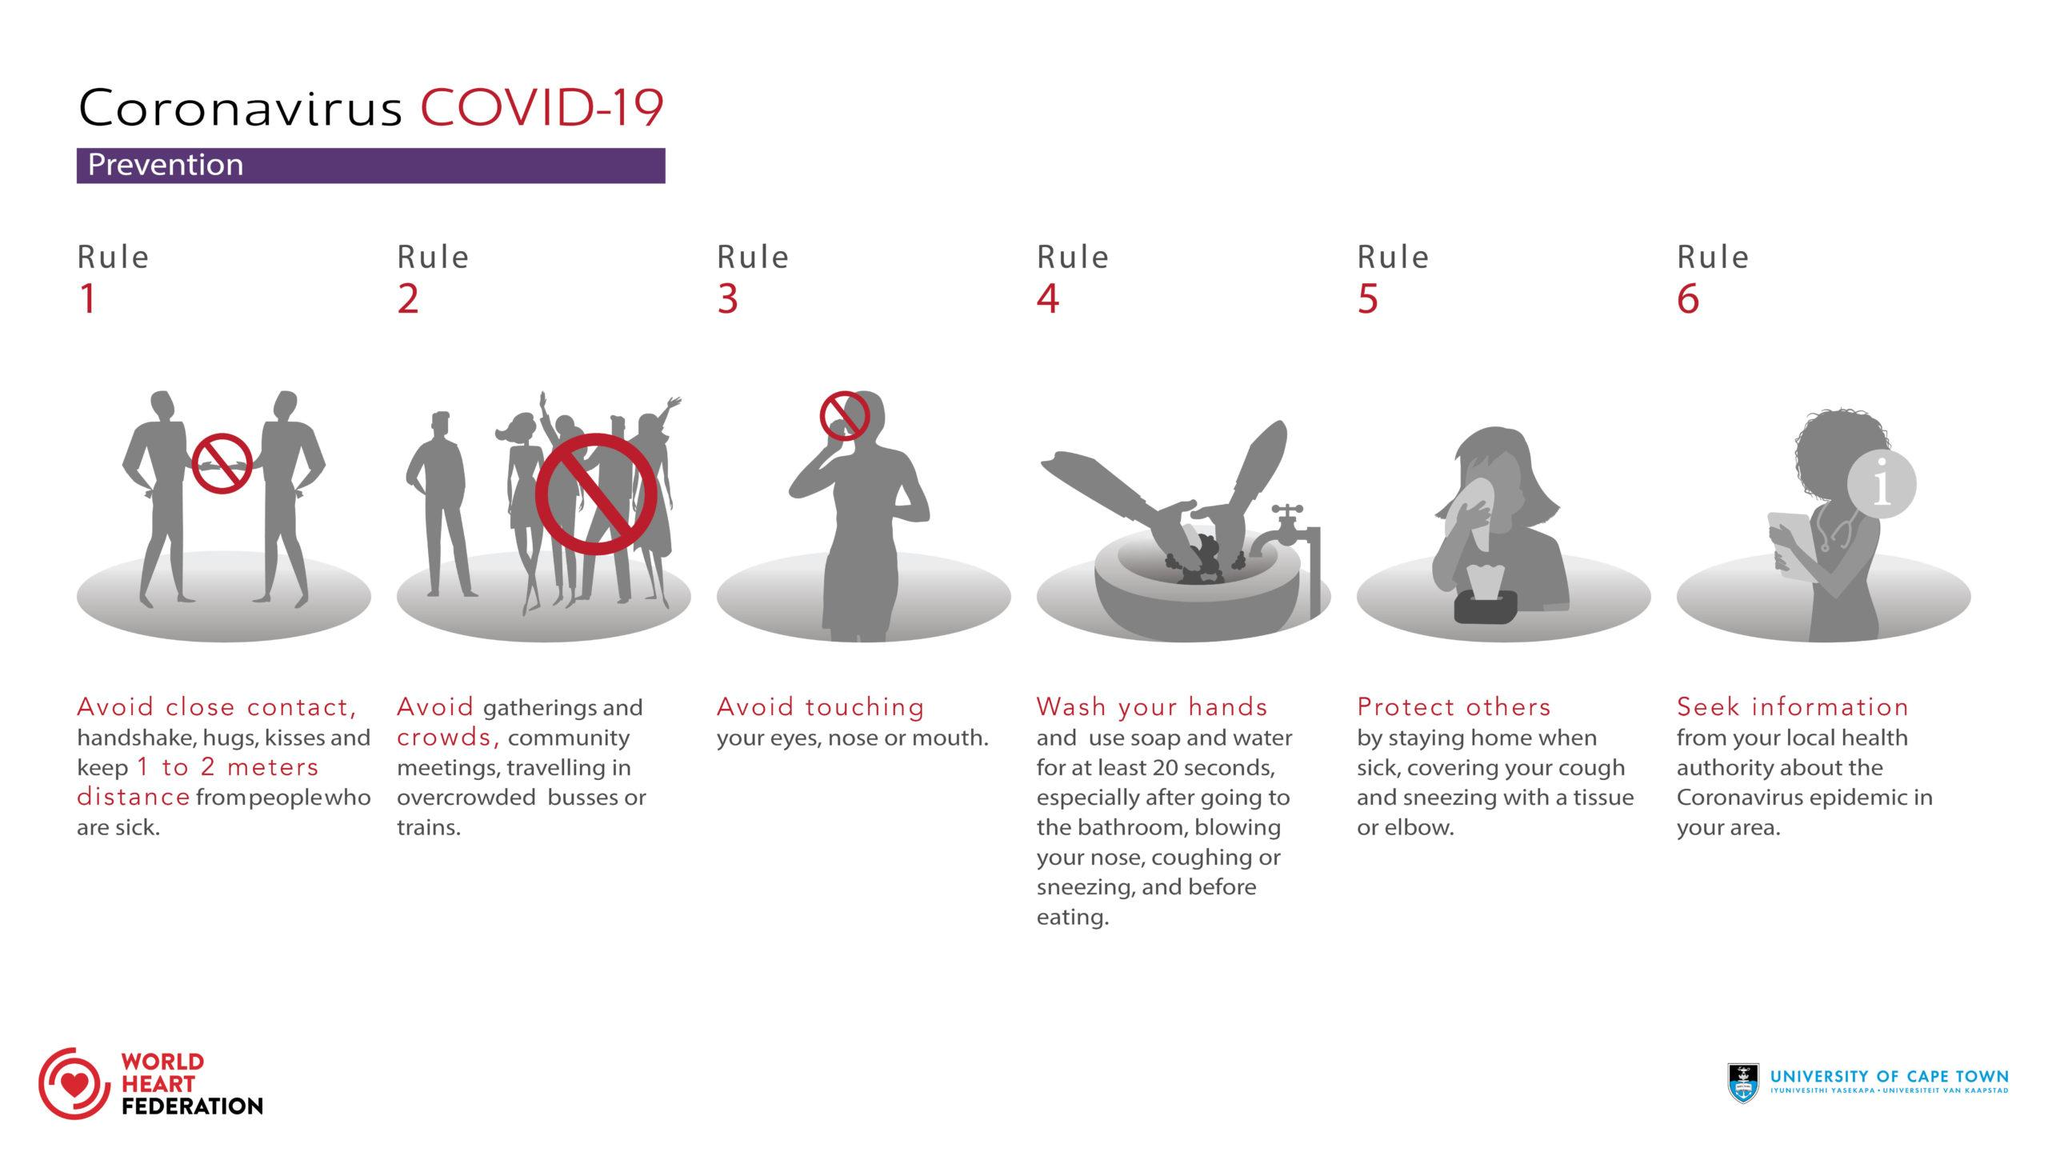Highlight a few significant elements in this photo. This infographic image shows a total of 3 items that are not present. 